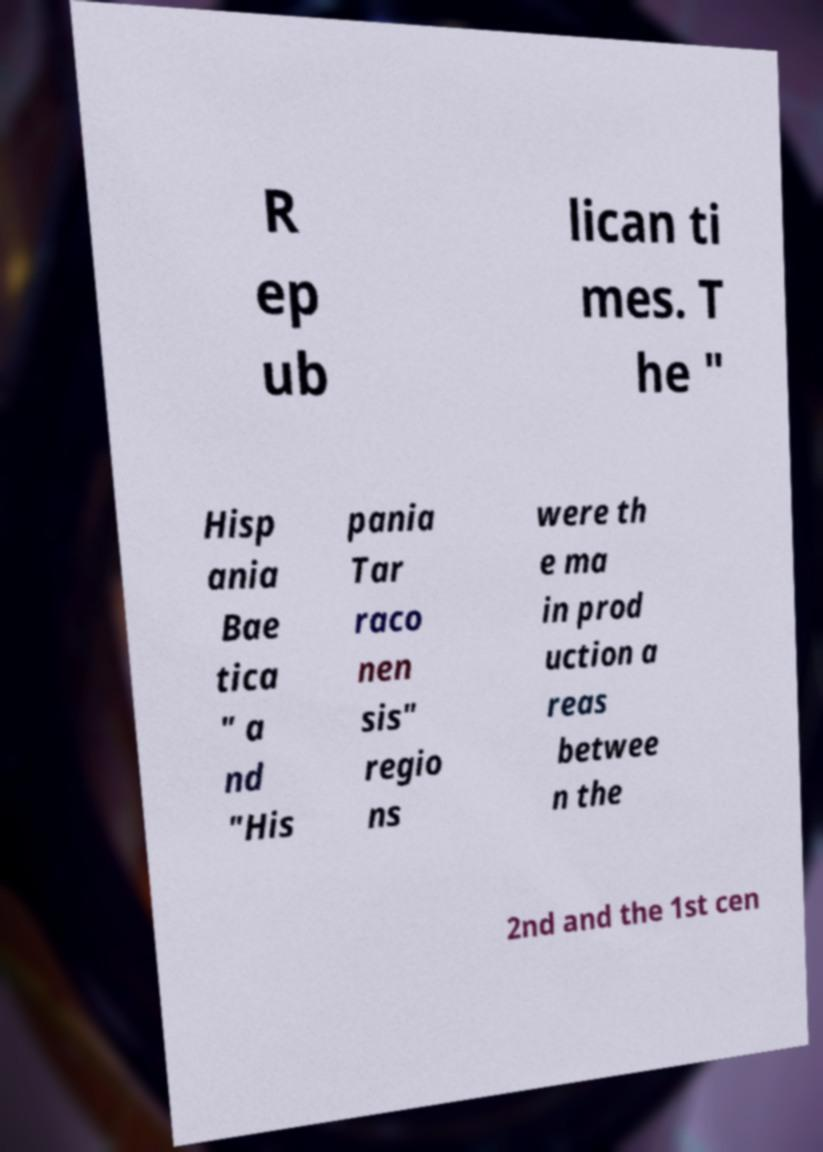For documentation purposes, I need the text within this image transcribed. Could you provide that? R ep ub lican ti mes. T he " Hisp ania Bae tica " a nd "His pania Tar raco nen sis" regio ns were th e ma in prod uction a reas betwee n the 2nd and the 1st cen 